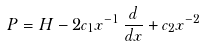Convert formula to latex. <formula><loc_0><loc_0><loc_500><loc_500>P = H - 2 c _ { 1 } x ^ { - 1 } \, \frac { d } { d x } + c _ { 2 } x ^ { - 2 }</formula> 